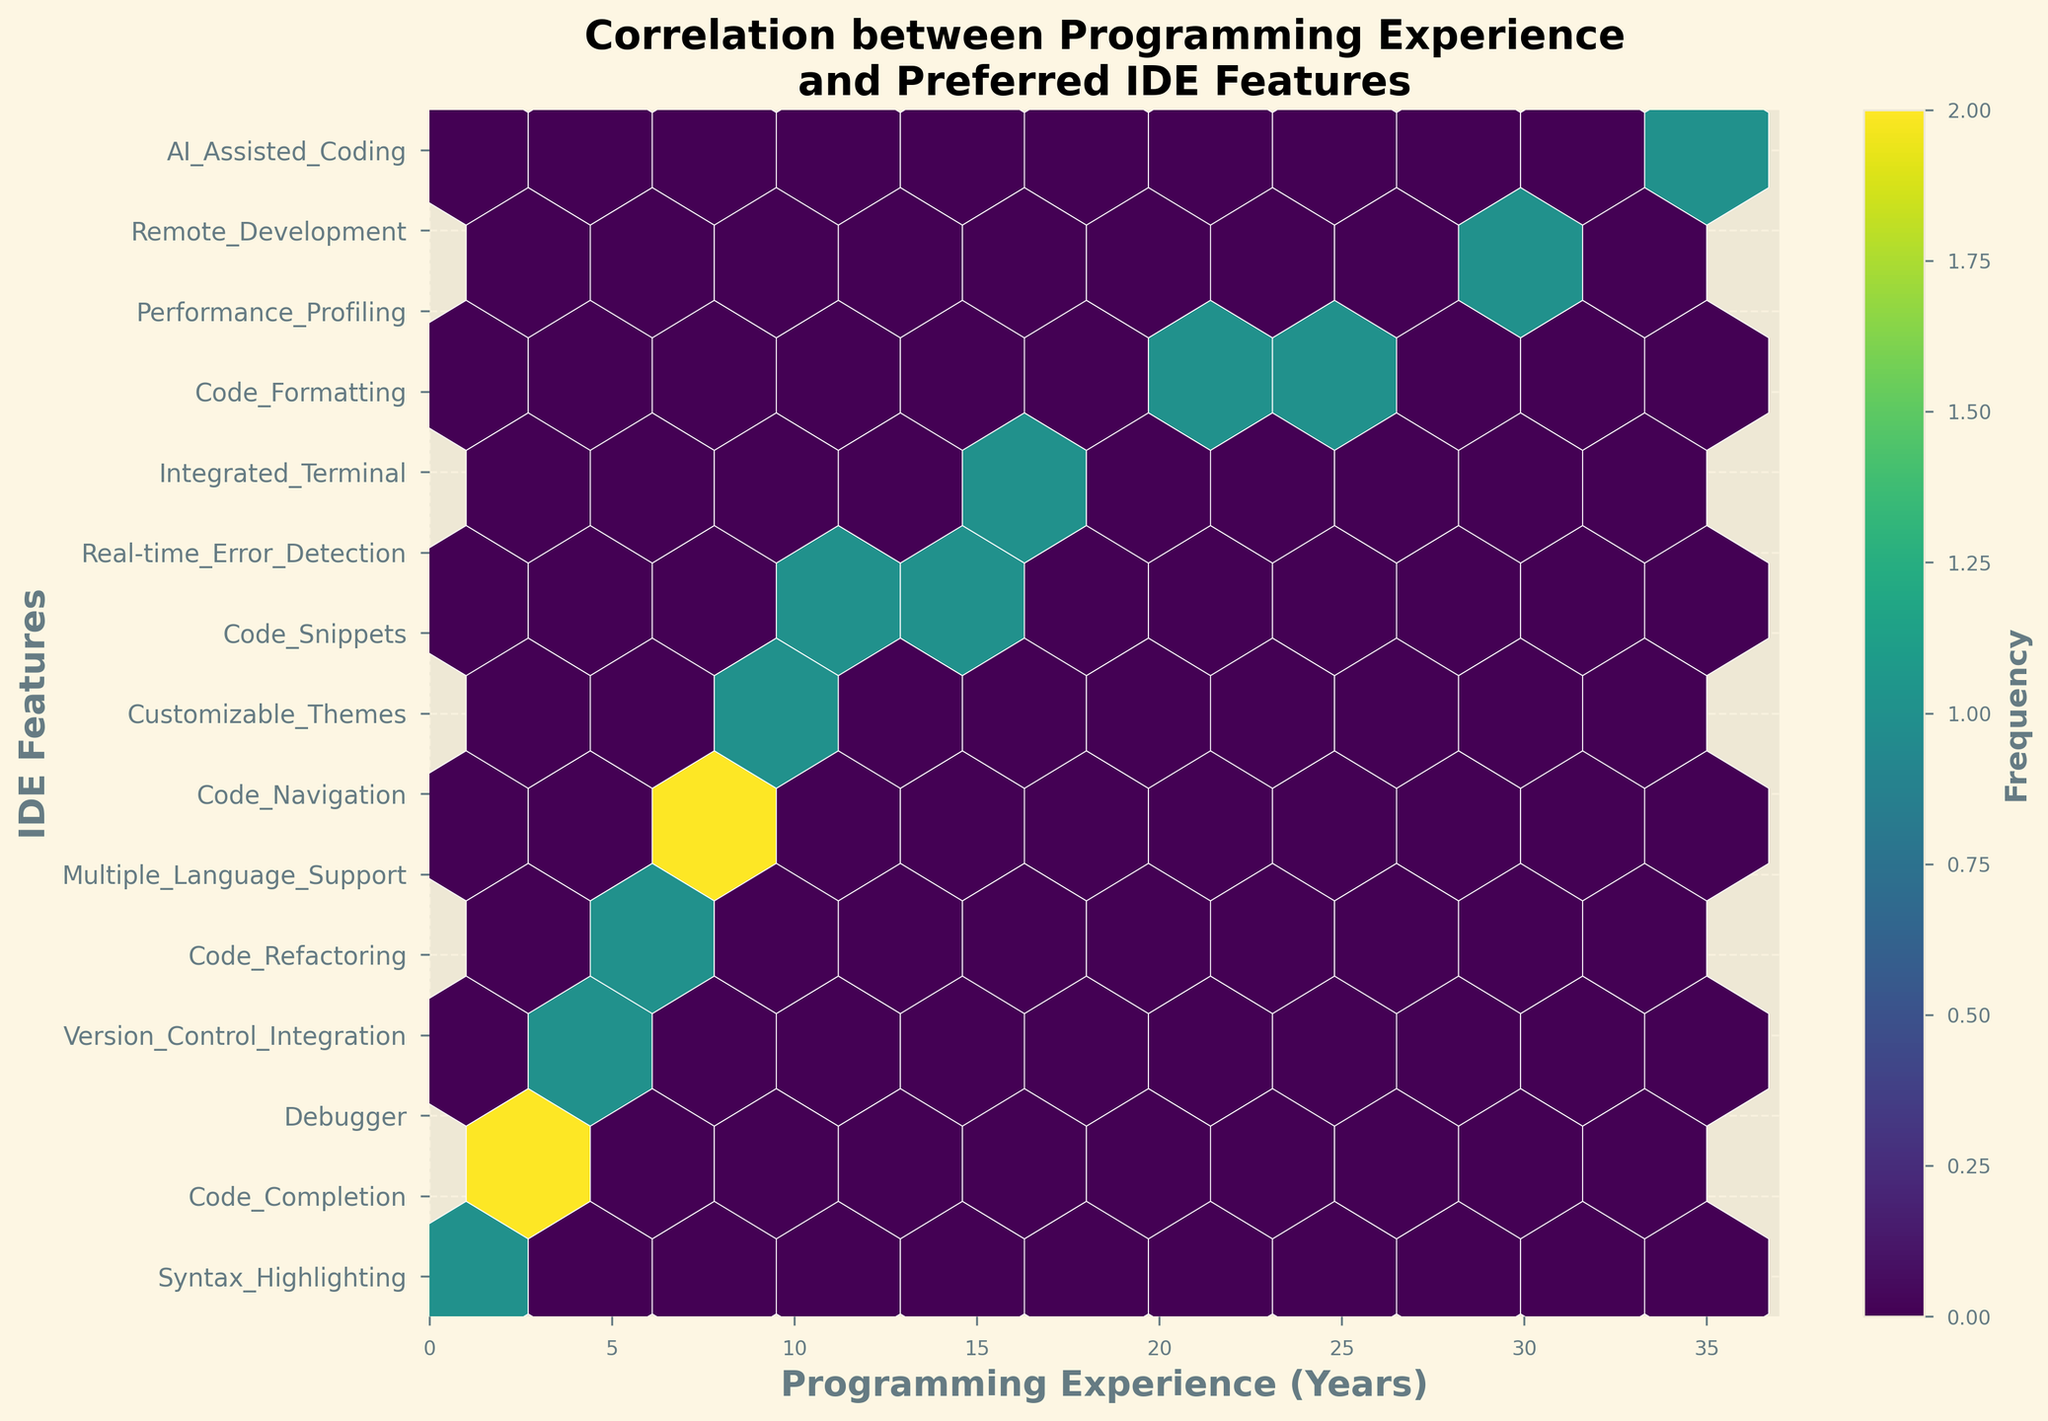What is the title of the figure? The title is displayed at the top of the figure. It reads "Correlation between Programming Experience and Preferred IDE Features."
Answer: Correlation between Programming Experience and Preferred IDE Features What are the labels of the x and y axes? The x-axis label is near the bottom of the horizontal axis, which reads "Programming Experience (Years)," and the y-axis label is along the left side of the vertical axis, reading "IDE Features."
Answer: Programming Experience (Years), IDE Features How many y-ticks (IDE features) are labeled on the y-axis? The figure has y-ticks corresponding to the number of IDE features, which can be counted directly from the labels on the y-axis. There are 15 labeled y-ticks.
Answer: 15 What color scheme is used in the hexbin plot? The color scheme, or colormap used in the hexbin plot, is primarily shades of green to deep purple, corresponding to the 'viridis' colormap.
Answer: viridis Which IDE feature correlates with the highest programming experience? The y-tick labels show the IDE features corresponding to different experience levels. The feature at the highest x value (35 years of experience) is "AI_Assisted_Coding."
Answer: AI_Assisted_Coding What is the range of the x-axis? The range of the x-axis is determined by the minimum and maximum values labeled on the x-axis. It extends from 0 to 32 years of programming experience.
Answer: 0 to 32 years What is the range of the color bar representing frequency? The range of the color bar, which is located adjacent to the hexbin plot, typically indicates the minimum and maximum frequency values it represents. By examining the color bar, one can see its range.
Answer: Minimum to maximum frequency Which IDE feature correlates closely with 10 years of programming experience? By finding the corresponding x value (10 years) and looking at the y-tick labels directly opposite that point, we can see that "Customizable_Themes" is the IDE feature near that experience level.
Answer: Customizable_Themes Is there a feature that appears more frequently than others in the hexbin plot? By examining the hexbin plot, we can find areas with darker colors that indicate higher frequency due to the color bar. These areas signify higher density and frequency of data points.
Answer: Yes, areas with darker greens to purples indicate higher frequency How does "Code_Completion" compare with "AI_Assisted_Coding" in terms of associated programming experience? "Code_Completion" is associated with 2 years of experience, while "AI_Assisted_Coding" is associated with 35 years of experience. Comparing them shows that "AI_Assisted_Coding" is associated with substantially higher experience.
Answer: "AI_Assisted_Coding" is associated with higher experience 